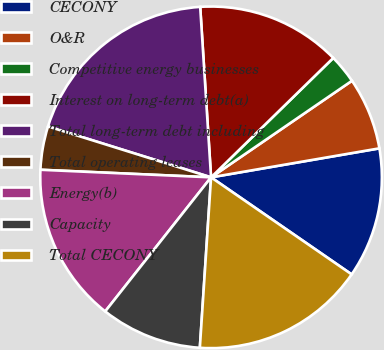<chart> <loc_0><loc_0><loc_500><loc_500><pie_chart><fcel>CECONY<fcel>O&R<fcel>Competitive energy businesses<fcel>Interest on long-term debt(a)<fcel>Total long-term debt including<fcel>Total operating leases<fcel>Energy(b)<fcel>Capacity<fcel>Total CECONY<nl><fcel>12.33%<fcel>6.85%<fcel>2.75%<fcel>13.7%<fcel>19.17%<fcel>4.11%<fcel>15.07%<fcel>9.59%<fcel>16.43%<nl></chart> 